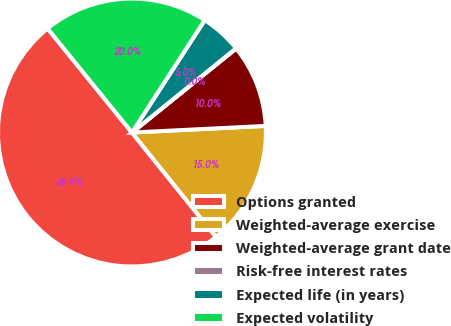Convert chart. <chart><loc_0><loc_0><loc_500><loc_500><pie_chart><fcel>Options granted<fcel>Weighted-average exercise<fcel>Weighted-average grant date<fcel>Risk-free interest rates<fcel>Expected life (in years)<fcel>Expected volatility<nl><fcel>49.94%<fcel>15.0%<fcel>10.01%<fcel>0.03%<fcel>5.02%<fcel>19.99%<nl></chart> 